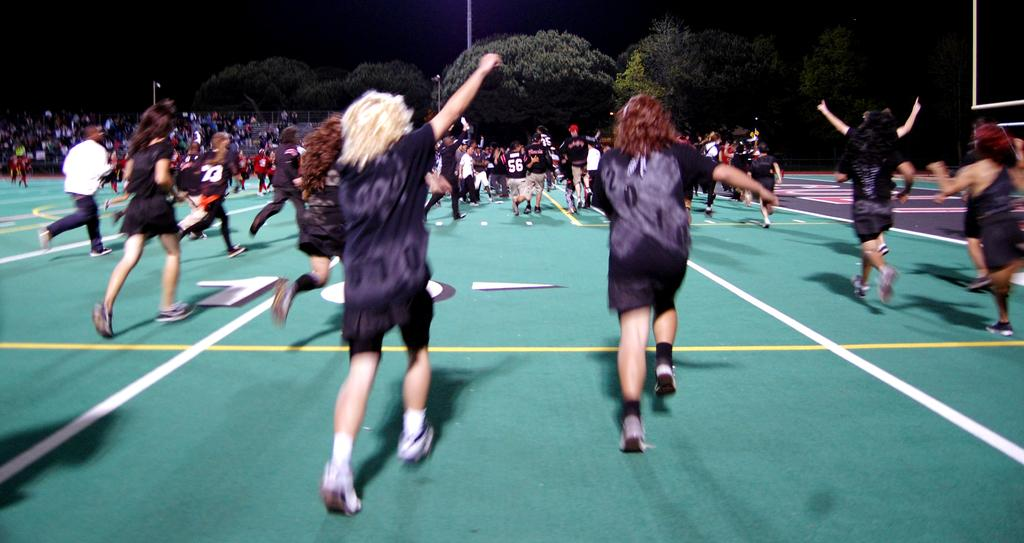What are the people in the image doing? There are people running in the image. What can be seen in front of the runners? There are spectators in front of the runners. What is visible in the background of the image? There are trees and a pole in the background of the image. What type of mask is the fireman wearing in the image? There is no fireman or mask present in the image. What shape is the object the runners are trying to form in the image? There is no indication of the runners forming a shape in the image. 